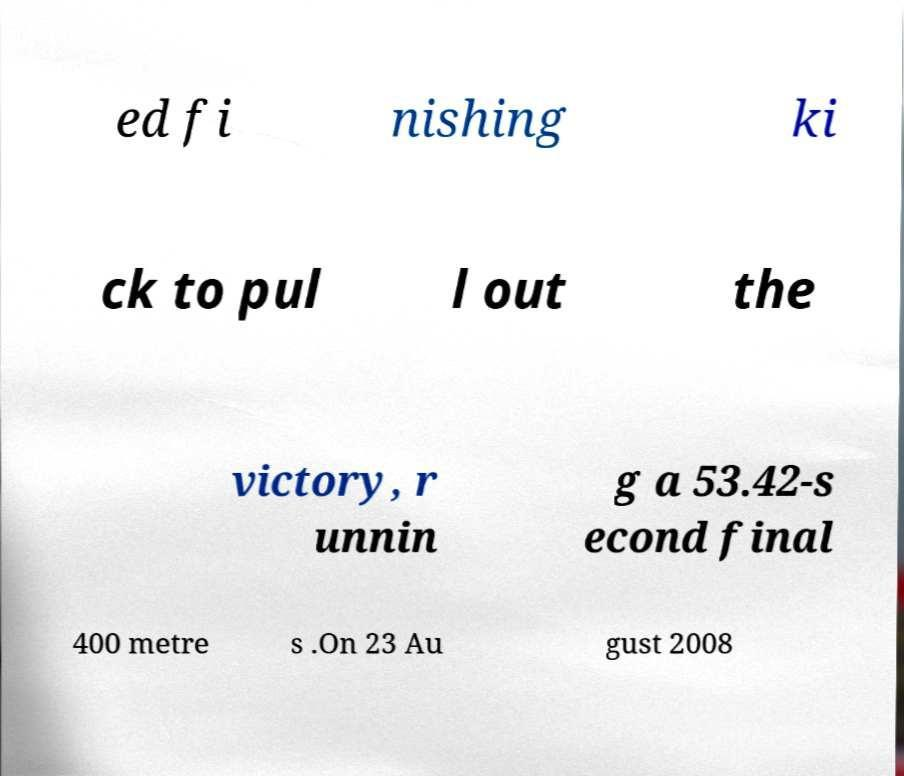Please read and relay the text visible in this image. What does it say? ed fi nishing ki ck to pul l out the victory, r unnin g a 53.42-s econd final 400 metre s .On 23 Au gust 2008 